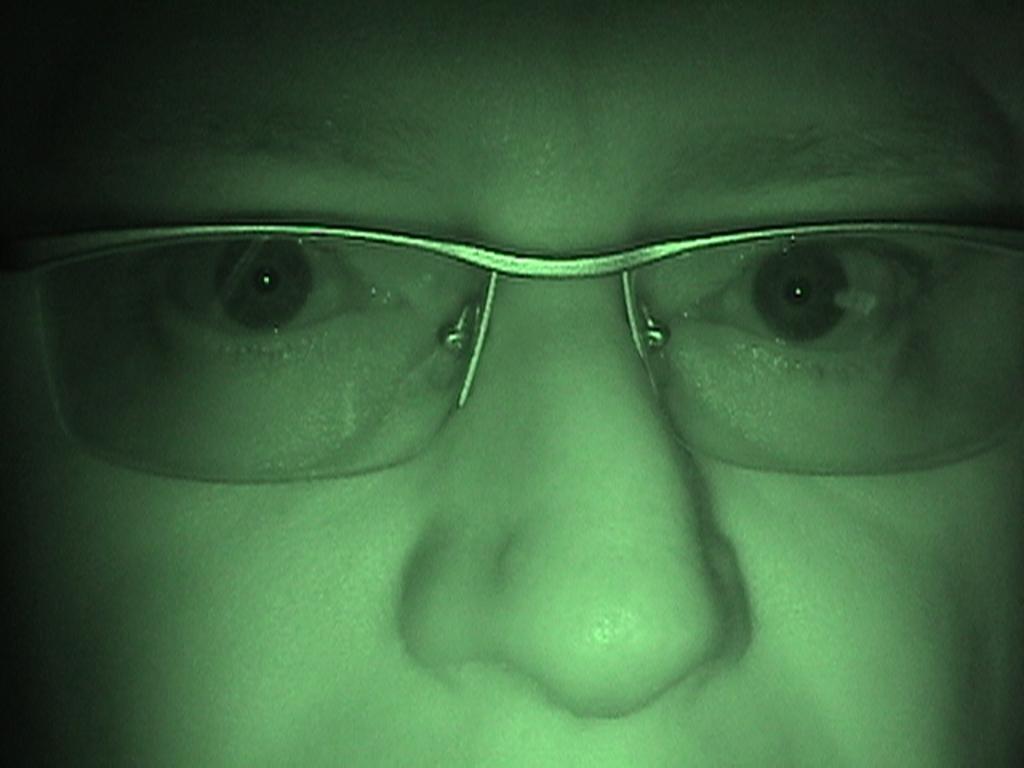In one or two sentences, can you explain what this image depicts? This image consists of a person. Only face is visible. He is wearing goggles. He has nose, eyes. 